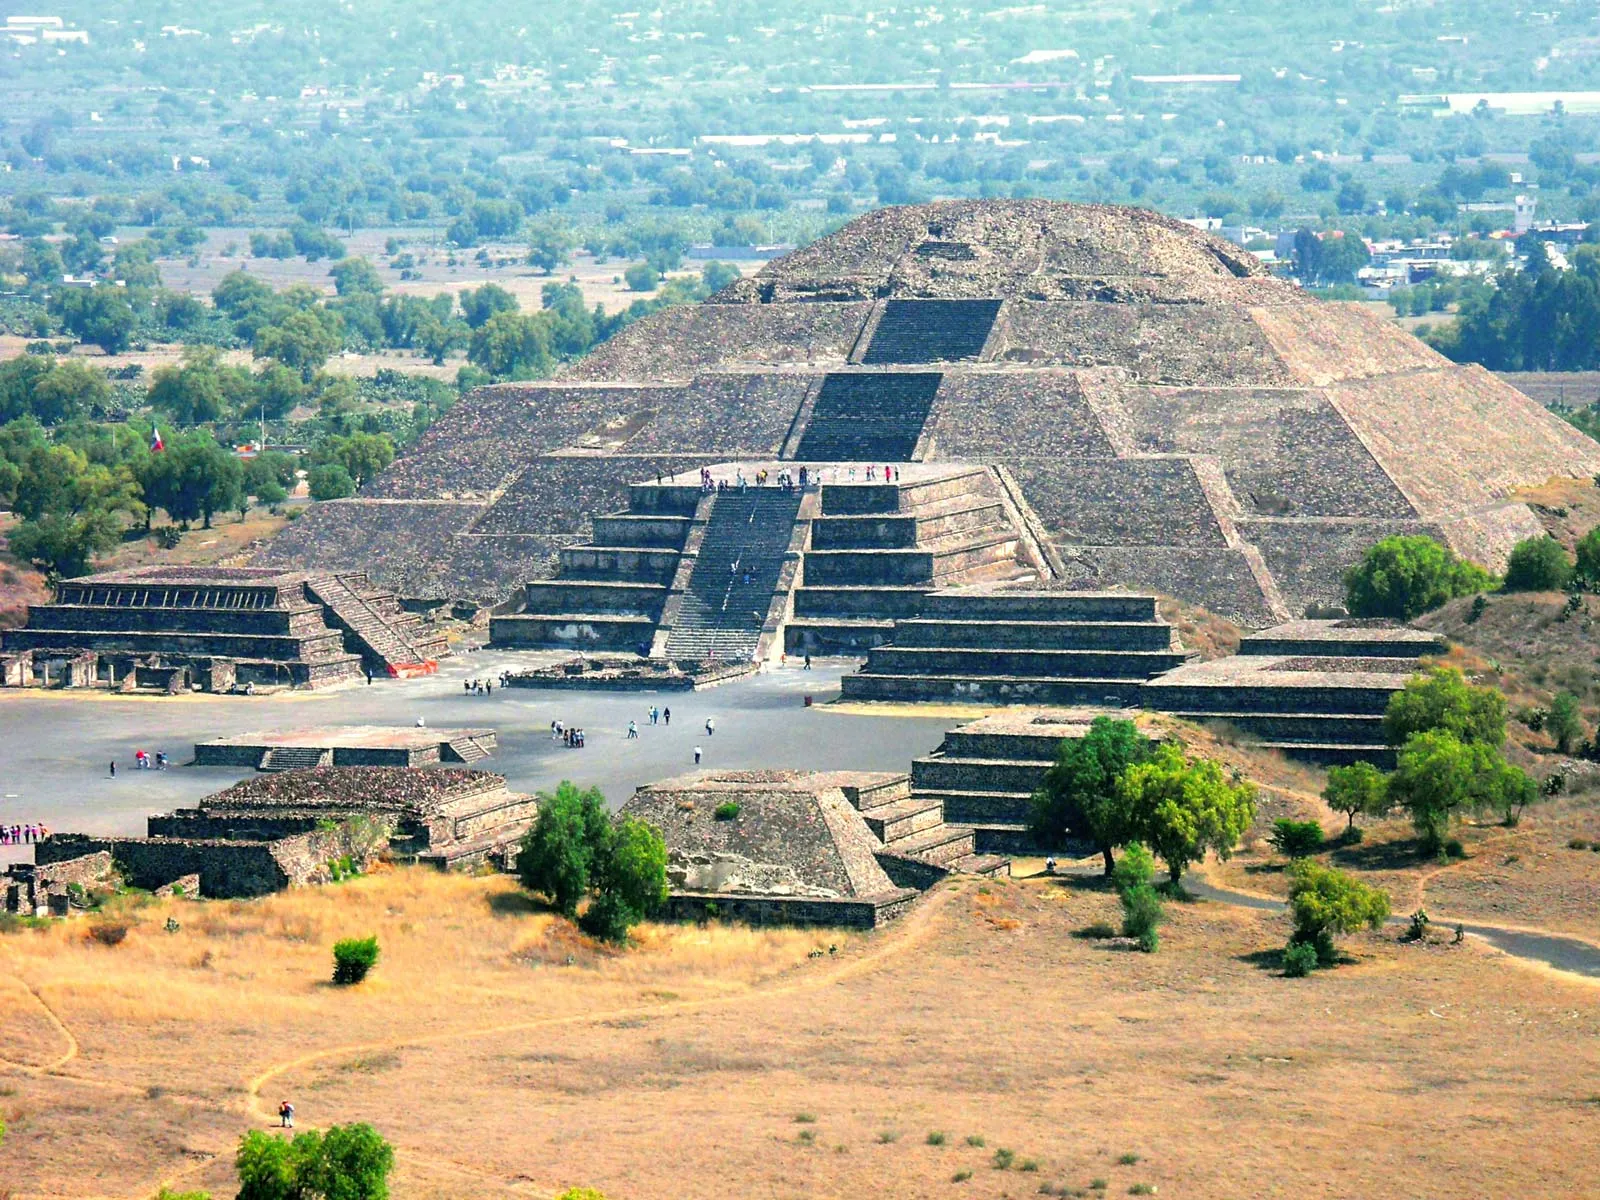Imagine the bustling life around this pyramid. What could daily activities have looked like in this ancient city? Imagining the daily life around the Pyramid of the Sun, one would see a vibrant hub of activity. The city of Teotihuacan was a thriving metropolis, and the area surrounding the pyramid would have been a focal point. Early in the morning, traders from various regions would set up their stalls, selling goods such as pottery, textiles, and food. Priests, adorned in ornate ceremonial garments, would conduct rituals on the pyramid’s steps, invoking blessings from the gods. Children might be seen playing around the smaller structures, while artisans worked diligently on their crafts. As the sun set, the pyramid would become a mesmerizing silhouette against the twilight sky, with the flickering lights of torches illuminating the ongoing celebrations and communal gatherings. 